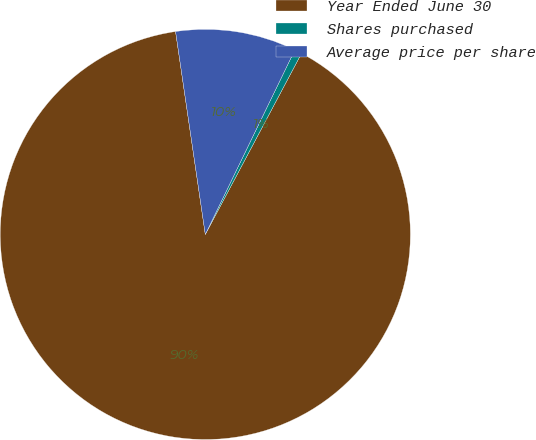Convert chart. <chart><loc_0><loc_0><loc_500><loc_500><pie_chart><fcel>Year Ended June 30<fcel>Shares purchased<fcel>Average price per share<nl><fcel>89.91%<fcel>0.58%<fcel>9.51%<nl></chart> 